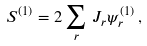<formula> <loc_0><loc_0><loc_500><loc_500>S ^ { ( 1 ) } = 2 \sum _ { r } \, J _ { r } \psi _ { r } ^ { ( 1 ) } \, ,</formula> 